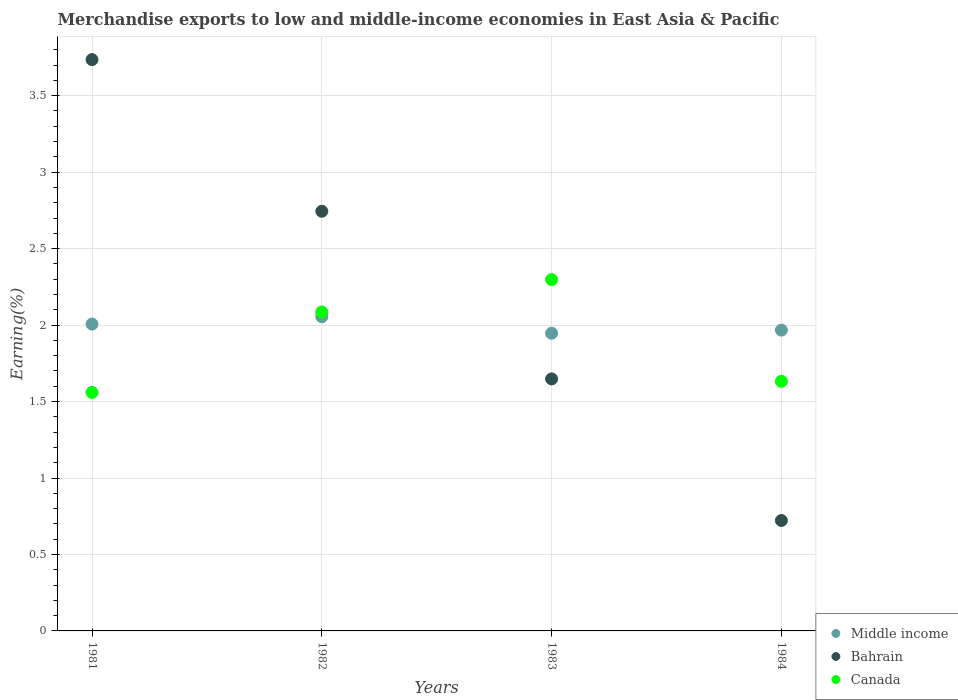How many different coloured dotlines are there?
Your answer should be very brief. 3. What is the percentage of amount earned from merchandise exports in Bahrain in 1984?
Provide a succinct answer. 0.72. Across all years, what is the maximum percentage of amount earned from merchandise exports in Bahrain?
Offer a very short reply. 3.74. Across all years, what is the minimum percentage of amount earned from merchandise exports in Middle income?
Your answer should be very brief. 1.95. In which year was the percentage of amount earned from merchandise exports in Canada maximum?
Ensure brevity in your answer.  1983. What is the total percentage of amount earned from merchandise exports in Canada in the graph?
Offer a very short reply. 7.58. What is the difference between the percentage of amount earned from merchandise exports in Bahrain in 1982 and that in 1983?
Keep it short and to the point. 1.1. What is the difference between the percentage of amount earned from merchandise exports in Middle income in 1984 and the percentage of amount earned from merchandise exports in Bahrain in 1983?
Offer a terse response. 0.32. What is the average percentage of amount earned from merchandise exports in Middle income per year?
Your answer should be compact. 1.99. In the year 1984, what is the difference between the percentage of amount earned from merchandise exports in Middle income and percentage of amount earned from merchandise exports in Bahrain?
Provide a succinct answer. 1.24. What is the ratio of the percentage of amount earned from merchandise exports in Bahrain in 1982 to that in 1983?
Provide a short and direct response. 1.67. Is the percentage of amount earned from merchandise exports in Middle income in 1983 less than that in 1984?
Offer a very short reply. Yes. What is the difference between the highest and the second highest percentage of amount earned from merchandise exports in Middle income?
Ensure brevity in your answer.  0.05. What is the difference between the highest and the lowest percentage of amount earned from merchandise exports in Canada?
Offer a very short reply. 0.74. Is it the case that in every year, the sum of the percentage of amount earned from merchandise exports in Canada and percentage of amount earned from merchandise exports in Middle income  is greater than the percentage of amount earned from merchandise exports in Bahrain?
Keep it short and to the point. No. Is the percentage of amount earned from merchandise exports in Canada strictly greater than the percentage of amount earned from merchandise exports in Bahrain over the years?
Make the answer very short. No. Is the percentage of amount earned from merchandise exports in Canada strictly less than the percentage of amount earned from merchandise exports in Bahrain over the years?
Provide a short and direct response. No. How many dotlines are there?
Make the answer very short. 3. How many years are there in the graph?
Your response must be concise. 4. Where does the legend appear in the graph?
Offer a very short reply. Bottom right. How are the legend labels stacked?
Offer a terse response. Vertical. What is the title of the graph?
Your answer should be compact. Merchandise exports to low and middle-income economies in East Asia & Pacific. Does "Zambia" appear as one of the legend labels in the graph?
Provide a succinct answer. No. What is the label or title of the Y-axis?
Ensure brevity in your answer.  Earning(%). What is the Earning(%) in Middle income in 1981?
Ensure brevity in your answer.  2.01. What is the Earning(%) in Bahrain in 1981?
Provide a short and direct response. 3.74. What is the Earning(%) in Canada in 1981?
Your answer should be very brief. 1.56. What is the Earning(%) in Middle income in 1982?
Make the answer very short. 2.05. What is the Earning(%) in Bahrain in 1982?
Offer a very short reply. 2.74. What is the Earning(%) of Canada in 1982?
Offer a terse response. 2.09. What is the Earning(%) in Middle income in 1983?
Make the answer very short. 1.95. What is the Earning(%) in Bahrain in 1983?
Your response must be concise. 1.65. What is the Earning(%) in Canada in 1983?
Your answer should be very brief. 2.3. What is the Earning(%) in Middle income in 1984?
Provide a short and direct response. 1.97. What is the Earning(%) of Bahrain in 1984?
Give a very brief answer. 0.72. What is the Earning(%) of Canada in 1984?
Give a very brief answer. 1.63. Across all years, what is the maximum Earning(%) of Middle income?
Your answer should be compact. 2.05. Across all years, what is the maximum Earning(%) of Bahrain?
Your answer should be very brief. 3.74. Across all years, what is the maximum Earning(%) in Canada?
Give a very brief answer. 2.3. Across all years, what is the minimum Earning(%) in Middle income?
Keep it short and to the point. 1.95. Across all years, what is the minimum Earning(%) in Bahrain?
Your response must be concise. 0.72. Across all years, what is the minimum Earning(%) in Canada?
Give a very brief answer. 1.56. What is the total Earning(%) of Middle income in the graph?
Your response must be concise. 7.98. What is the total Earning(%) of Bahrain in the graph?
Your answer should be very brief. 8.85. What is the total Earning(%) of Canada in the graph?
Ensure brevity in your answer.  7.58. What is the difference between the Earning(%) in Middle income in 1981 and that in 1982?
Your answer should be compact. -0.05. What is the difference between the Earning(%) in Bahrain in 1981 and that in 1982?
Give a very brief answer. 0.99. What is the difference between the Earning(%) in Canada in 1981 and that in 1982?
Your answer should be compact. -0.53. What is the difference between the Earning(%) of Middle income in 1981 and that in 1983?
Keep it short and to the point. 0.06. What is the difference between the Earning(%) in Bahrain in 1981 and that in 1983?
Offer a very short reply. 2.09. What is the difference between the Earning(%) of Canada in 1981 and that in 1983?
Offer a very short reply. -0.74. What is the difference between the Earning(%) of Middle income in 1981 and that in 1984?
Offer a terse response. 0.04. What is the difference between the Earning(%) of Bahrain in 1981 and that in 1984?
Make the answer very short. 3.01. What is the difference between the Earning(%) of Canada in 1981 and that in 1984?
Your response must be concise. -0.07. What is the difference between the Earning(%) of Middle income in 1982 and that in 1983?
Your answer should be compact. 0.11. What is the difference between the Earning(%) of Bahrain in 1982 and that in 1983?
Ensure brevity in your answer.  1.1. What is the difference between the Earning(%) of Canada in 1982 and that in 1983?
Provide a succinct answer. -0.21. What is the difference between the Earning(%) in Middle income in 1982 and that in 1984?
Your answer should be compact. 0.09. What is the difference between the Earning(%) of Bahrain in 1982 and that in 1984?
Your answer should be very brief. 2.02. What is the difference between the Earning(%) in Canada in 1982 and that in 1984?
Offer a terse response. 0.45. What is the difference between the Earning(%) of Middle income in 1983 and that in 1984?
Your answer should be compact. -0.02. What is the difference between the Earning(%) in Bahrain in 1983 and that in 1984?
Your answer should be very brief. 0.93. What is the difference between the Earning(%) in Canada in 1983 and that in 1984?
Provide a short and direct response. 0.67. What is the difference between the Earning(%) of Middle income in 1981 and the Earning(%) of Bahrain in 1982?
Offer a terse response. -0.74. What is the difference between the Earning(%) in Middle income in 1981 and the Earning(%) in Canada in 1982?
Your answer should be very brief. -0.08. What is the difference between the Earning(%) of Bahrain in 1981 and the Earning(%) of Canada in 1982?
Provide a short and direct response. 1.65. What is the difference between the Earning(%) of Middle income in 1981 and the Earning(%) of Bahrain in 1983?
Keep it short and to the point. 0.36. What is the difference between the Earning(%) in Middle income in 1981 and the Earning(%) in Canada in 1983?
Offer a very short reply. -0.29. What is the difference between the Earning(%) of Bahrain in 1981 and the Earning(%) of Canada in 1983?
Offer a very short reply. 1.44. What is the difference between the Earning(%) of Middle income in 1981 and the Earning(%) of Bahrain in 1984?
Your answer should be compact. 1.28. What is the difference between the Earning(%) of Middle income in 1981 and the Earning(%) of Canada in 1984?
Give a very brief answer. 0.37. What is the difference between the Earning(%) of Bahrain in 1981 and the Earning(%) of Canada in 1984?
Give a very brief answer. 2.1. What is the difference between the Earning(%) in Middle income in 1982 and the Earning(%) in Bahrain in 1983?
Offer a very short reply. 0.41. What is the difference between the Earning(%) of Middle income in 1982 and the Earning(%) of Canada in 1983?
Your response must be concise. -0.24. What is the difference between the Earning(%) in Bahrain in 1982 and the Earning(%) in Canada in 1983?
Give a very brief answer. 0.45. What is the difference between the Earning(%) in Middle income in 1982 and the Earning(%) in Bahrain in 1984?
Provide a succinct answer. 1.33. What is the difference between the Earning(%) of Middle income in 1982 and the Earning(%) of Canada in 1984?
Ensure brevity in your answer.  0.42. What is the difference between the Earning(%) of Bahrain in 1982 and the Earning(%) of Canada in 1984?
Provide a succinct answer. 1.11. What is the difference between the Earning(%) of Middle income in 1983 and the Earning(%) of Bahrain in 1984?
Give a very brief answer. 1.22. What is the difference between the Earning(%) of Middle income in 1983 and the Earning(%) of Canada in 1984?
Keep it short and to the point. 0.31. What is the difference between the Earning(%) of Bahrain in 1983 and the Earning(%) of Canada in 1984?
Your answer should be compact. 0.02. What is the average Earning(%) in Middle income per year?
Provide a short and direct response. 1.99. What is the average Earning(%) in Bahrain per year?
Provide a succinct answer. 2.21. What is the average Earning(%) of Canada per year?
Your response must be concise. 1.89. In the year 1981, what is the difference between the Earning(%) in Middle income and Earning(%) in Bahrain?
Your answer should be very brief. -1.73. In the year 1981, what is the difference between the Earning(%) of Middle income and Earning(%) of Canada?
Provide a succinct answer. 0.45. In the year 1981, what is the difference between the Earning(%) in Bahrain and Earning(%) in Canada?
Give a very brief answer. 2.18. In the year 1982, what is the difference between the Earning(%) of Middle income and Earning(%) of Bahrain?
Your answer should be compact. -0.69. In the year 1982, what is the difference between the Earning(%) in Middle income and Earning(%) in Canada?
Make the answer very short. -0.03. In the year 1982, what is the difference between the Earning(%) of Bahrain and Earning(%) of Canada?
Keep it short and to the point. 0.66. In the year 1983, what is the difference between the Earning(%) in Middle income and Earning(%) in Bahrain?
Ensure brevity in your answer.  0.3. In the year 1983, what is the difference between the Earning(%) of Middle income and Earning(%) of Canada?
Offer a very short reply. -0.35. In the year 1983, what is the difference between the Earning(%) of Bahrain and Earning(%) of Canada?
Make the answer very short. -0.65. In the year 1984, what is the difference between the Earning(%) of Middle income and Earning(%) of Bahrain?
Offer a very short reply. 1.25. In the year 1984, what is the difference between the Earning(%) of Middle income and Earning(%) of Canada?
Give a very brief answer. 0.34. In the year 1984, what is the difference between the Earning(%) in Bahrain and Earning(%) in Canada?
Ensure brevity in your answer.  -0.91. What is the ratio of the Earning(%) of Middle income in 1981 to that in 1982?
Your answer should be very brief. 0.98. What is the ratio of the Earning(%) of Bahrain in 1981 to that in 1982?
Your answer should be very brief. 1.36. What is the ratio of the Earning(%) of Canada in 1981 to that in 1982?
Your answer should be compact. 0.75. What is the ratio of the Earning(%) in Middle income in 1981 to that in 1983?
Give a very brief answer. 1.03. What is the ratio of the Earning(%) in Bahrain in 1981 to that in 1983?
Give a very brief answer. 2.27. What is the ratio of the Earning(%) in Canada in 1981 to that in 1983?
Offer a very short reply. 0.68. What is the ratio of the Earning(%) of Bahrain in 1981 to that in 1984?
Provide a succinct answer. 5.17. What is the ratio of the Earning(%) of Canada in 1981 to that in 1984?
Your answer should be very brief. 0.96. What is the ratio of the Earning(%) in Middle income in 1982 to that in 1983?
Offer a terse response. 1.06. What is the ratio of the Earning(%) of Bahrain in 1982 to that in 1983?
Offer a very short reply. 1.67. What is the ratio of the Earning(%) in Canada in 1982 to that in 1983?
Make the answer very short. 0.91. What is the ratio of the Earning(%) of Middle income in 1982 to that in 1984?
Make the answer very short. 1.04. What is the ratio of the Earning(%) of Bahrain in 1982 to that in 1984?
Give a very brief answer. 3.8. What is the ratio of the Earning(%) in Canada in 1982 to that in 1984?
Make the answer very short. 1.28. What is the ratio of the Earning(%) in Middle income in 1983 to that in 1984?
Your response must be concise. 0.99. What is the ratio of the Earning(%) of Bahrain in 1983 to that in 1984?
Provide a short and direct response. 2.28. What is the ratio of the Earning(%) of Canada in 1983 to that in 1984?
Ensure brevity in your answer.  1.41. What is the difference between the highest and the second highest Earning(%) in Middle income?
Offer a very short reply. 0.05. What is the difference between the highest and the second highest Earning(%) of Canada?
Give a very brief answer. 0.21. What is the difference between the highest and the lowest Earning(%) in Middle income?
Keep it short and to the point. 0.11. What is the difference between the highest and the lowest Earning(%) in Bahrain?
Provide a succinct answer. 3.01. What is the difference between the highest and the lowest Earning(%) of Canada?
Ensure brevity in your answer.  0.74. 